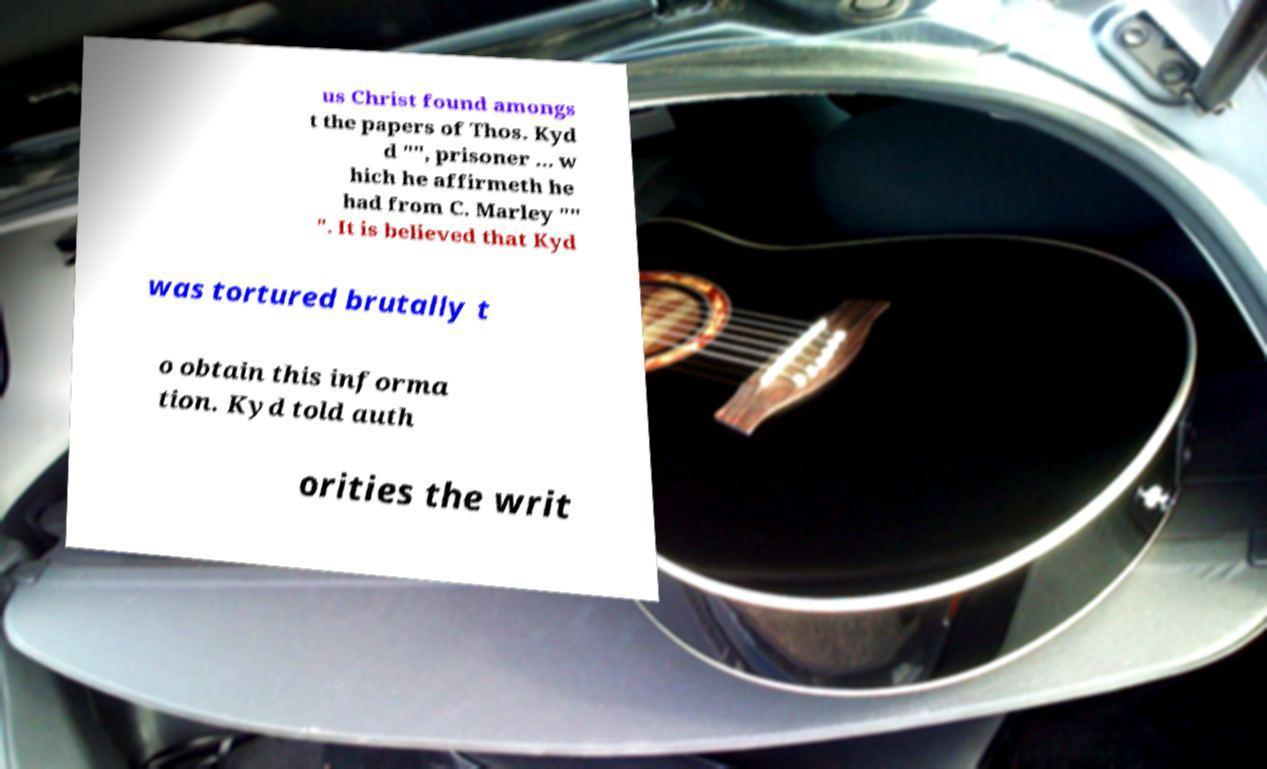What messages or text are displayed in this image? I need them in a readable, typed format. us Christ found amongs t the papers of Thos. Kyd d "", prisoner ... w hich he affirmeth he had from C. Marley "" ". It is believed that Kyd was tortured brutally t o obtain this informa tion. Kyd told auth orities the writ 